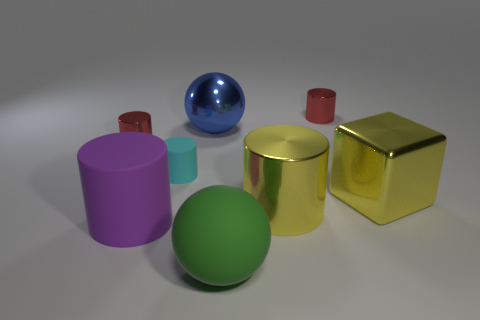Subtract all cyan cylinders. How many cylinders are left? 4 Subtract all large yellow cylinders. How many cylinders are left? 4 Add 1 large matte objects. How many objects exist? 9 Subtract all blocks. How many objects are left? 7 Subtract all blue cylinders. Subtract all blue balls. How many cylinders are left? 5 Add 8 cyan blocks. How many cyan blocks exist? 8 Subtract 0 brown cubes. How many objects are left? 8 Subtract all tiny red metallic cylinders. Subtract all red metal cylinders. How many objects are left? 4 Add 6 red cylinders. How many red cylinders are left? 8 